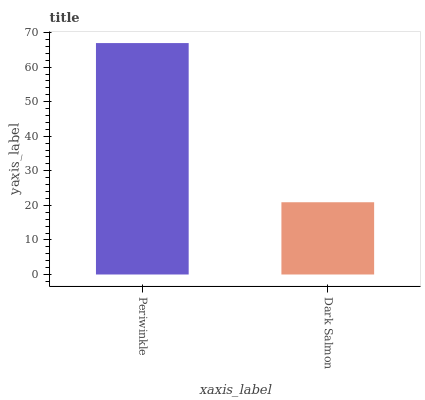Is Dark Salmon the minimum?
Answer yes or no. Yes. Is Periwinkle the maximum?
Answer yes or no. Yes. Is Dark Salmon the maximum?
Answer yes or no. No. Is Periwinkle greater than Dark Salmon?
Answer yes or no. Yes. Is Dark Salmon less than Periwinkle?
Answer yes or no. Yes. Is Dark Salmon greater than Periwinkle?
Answer yes or no. No. Is Periwinkle less than Dark Salmon?
Answer yes or no. No. Is Periwinkle the high median?
Answer yes or no. Yes. Is Dark Salmon the low median?
Answer yes or no. Yes. Is Dark Salmon the high median?
Answer yes or no. No. Is Periwinkle the low median?
Answer yes or no. No. 